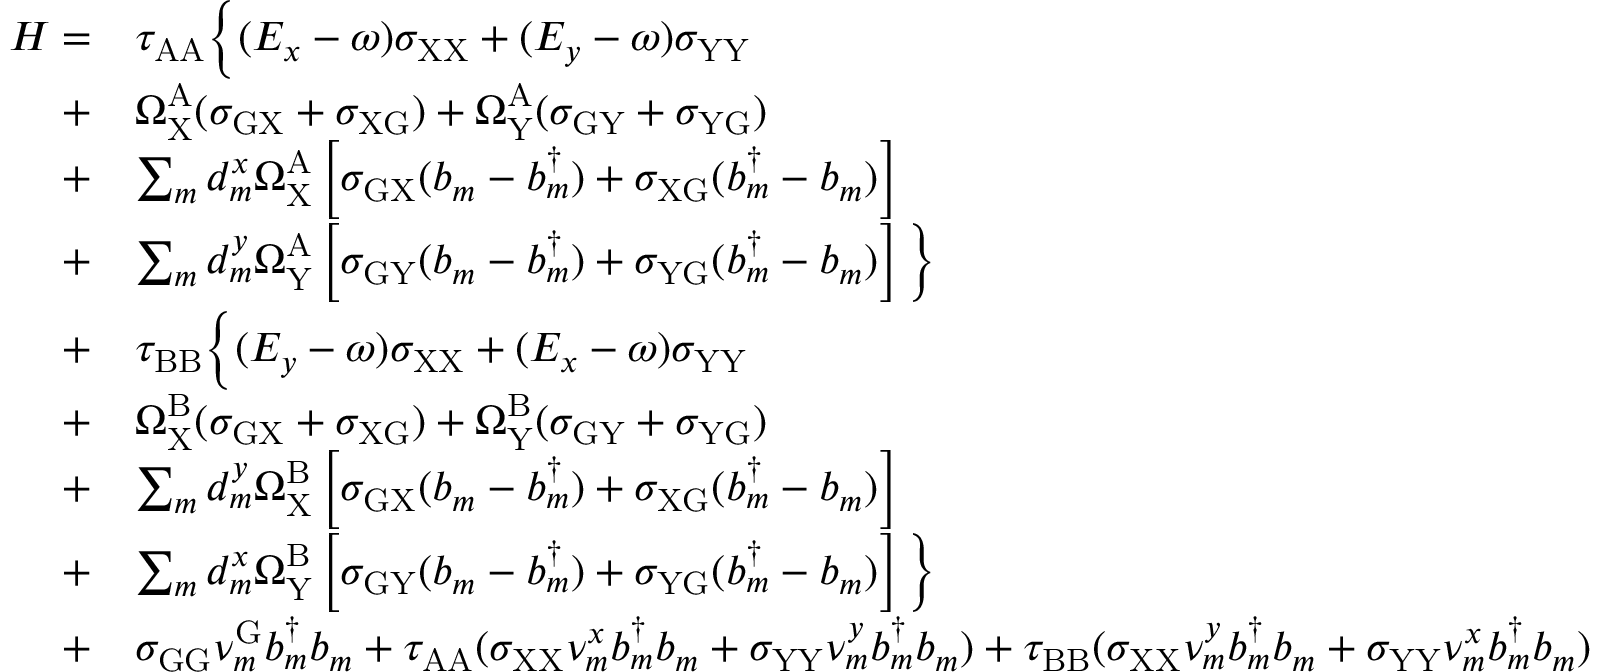Convert formula to latex. <formula><loc_0><loc_0><loc_500><loc_500>\begin{array} { r l } { H = } & { \tau _ { A A } \left \{ ( E _ { x } - \omega ) \sigma _ { X X } + ( E _ { y } - \omega ) \sigma _ { Y Y } } \\ { + } & { \Omega _ { X } ^ { A } ( \sigma _ { G X } + \sigma _ { X G } ) + \Omega _ { Y } ^ { A } ( \sigma _ { G Y } + \sigma _ { Y G } ) } \\ { + } & { \sum _ { m } d _ { m } ^ { x } \Omega _ { X } ^ { A } \left [ \sigma _ { G X } ( b _ { m } - b _ { m } ^ { \dagger } ) + \sigma _ { X G } ( b _ { m } ^ { \dagger } - b _ { m } ) \right ] } \\ { + } & { \sum _ { m } d _ { m } ^ { y } \Omega _ { Y } ^ { A } \left [ \sigma _ { G Y } ( b _ { m } - b _ { m } ^ { \dagger } ) + \sigma _ { Y G } ( b _ { m } ^ { \dagger } - b _ { m } ) \right ] \right \} } \\ { + } & { \tau _ { B B } \left \{ ( E _ { y } - \omega ) \sigma _ { X X } + ( E _ { x } - \omega ) \sigma _ { Y Y } } \\ { + } & { \Omega _ { X } ^ { B } ( \sigma _ { G X } + \sigma _ { X G } ) + \Omega _ { Y } ^ { B } ( \sigma _ { G Y } + \sigma _ { Y G } ) } \\ { + } & { \sum _ { m } d _ { m } ^ { y } \Omega _ { X } ^ { B } \left [ \sigma _ { G X } ( b _ { m } - b _ { m } ^ { \dagger } ) + \sigma _ { X G } ( b _ { m } ^ { \dagger } - b _ { m } ) \right ] } \\ { + } & { \sum _ { m } d _ { m } ^ { x } \Omega _ { Y } ^ { B } \left [ \sigma _ { G Y } ( b _ { m } - b _ { m } ^ { \dagger } ) + \sigma _ { Y G } ( b _ { m } ^ { \dagger } - b _ { m } ) \right ] \right \} } \\ { + } & { \sigma _ { G G } \nu _ { m } ^ { G } b _ { m } ^ { \dagger } b _ { m } + \tau _ { A A } ( \sigma _ { X X } \nu _ { m } ^ { x } b _ { m } ^ { \dagger } b _ { m } + \sigma _ { Y Y } \nu _ { m } ^ { y } b _ { m } ^ { \dagger } b _ { m } ) + \tau _ { B B } ( \sigma _ { X X } \nu _ { m } ^ { y } b _ { m } ^ { \dagger } b _ { m } + \sigma _ { Y Y } \nu _ { m } ^ { x } b _ { m } ^ { \dagger } b _ { m } ) } \end{array}</formula> 